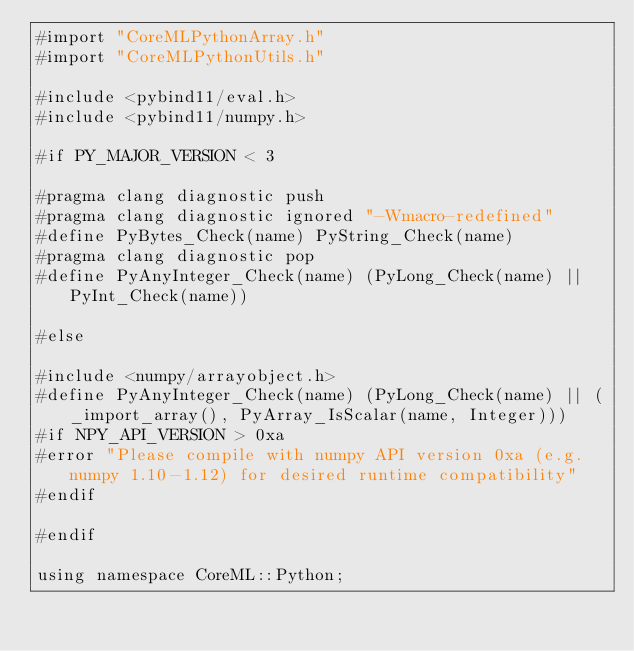Convert code to text. <code><loc_0><loc_0><loc_500><loc_500><_ObjectiveC_>#import "CoreMLPythonArray.h"
#import "CoreMLPythonUtils.h"

#include <pybind11/eval.h>
#include <pybind11/numpy.h>

#if PY_MAJOR_VERSION < 3

#pragma clang diagnostic push
#pragma clang diagnostic ignored "-Wmacro-redefined"
#define PyBytes_Check(name) PyString_Check(name)
#pragma clang diagnostic pop
#define PyAnyInteger_Check(name) (PyLong_Check(name) || PyInt_Check(name))

#else

#include <numpy/arrayobject.h>
#define PyAnyInteger_Check(name) (PyLong_Check(name) || (_import_array(), PyArray_IsScalar(name, Integer)))
#if NPY_API_VERSION > 0xa
#error "Please compile with numpy API version 0xa (e.g. numpy 1.10-1.12) for desired runtime compatibility"
#endif

#endif

using namespace CoreML::Python;
</code> 